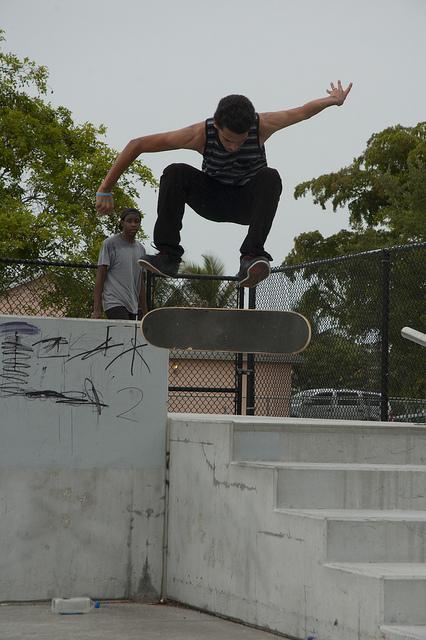How many people are in the photo?
Give a very brief answer. 2. How many zebras are facing the camera?
Give a very brief answer. 0. 